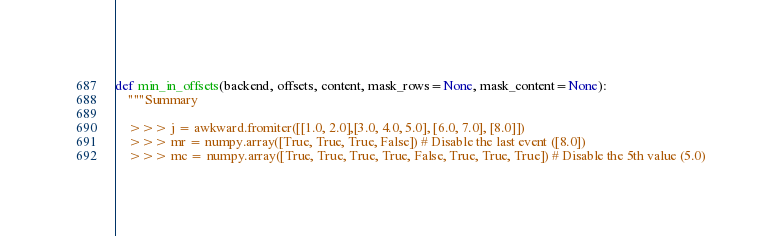<code> <loc_0><loc_0><loc_500><loc_500><_Python_>

def min_in_offsets(backend, offsets, content, mask_rows=None, mask_content=None):
    """Summary

    >>> j = awkward.fromiter([[1.0, 2.0],[3.0, 4.0, 5.0], [6.0, 7.0], [8.0]])
    >>> mr = numpy.array([True, True, True, False]) # Disable the last event ([8.0])
    >>> mc = numpy.array([True, True, True, True, False, True, True, True]) # Disable the 5th value (5.0)</code> 